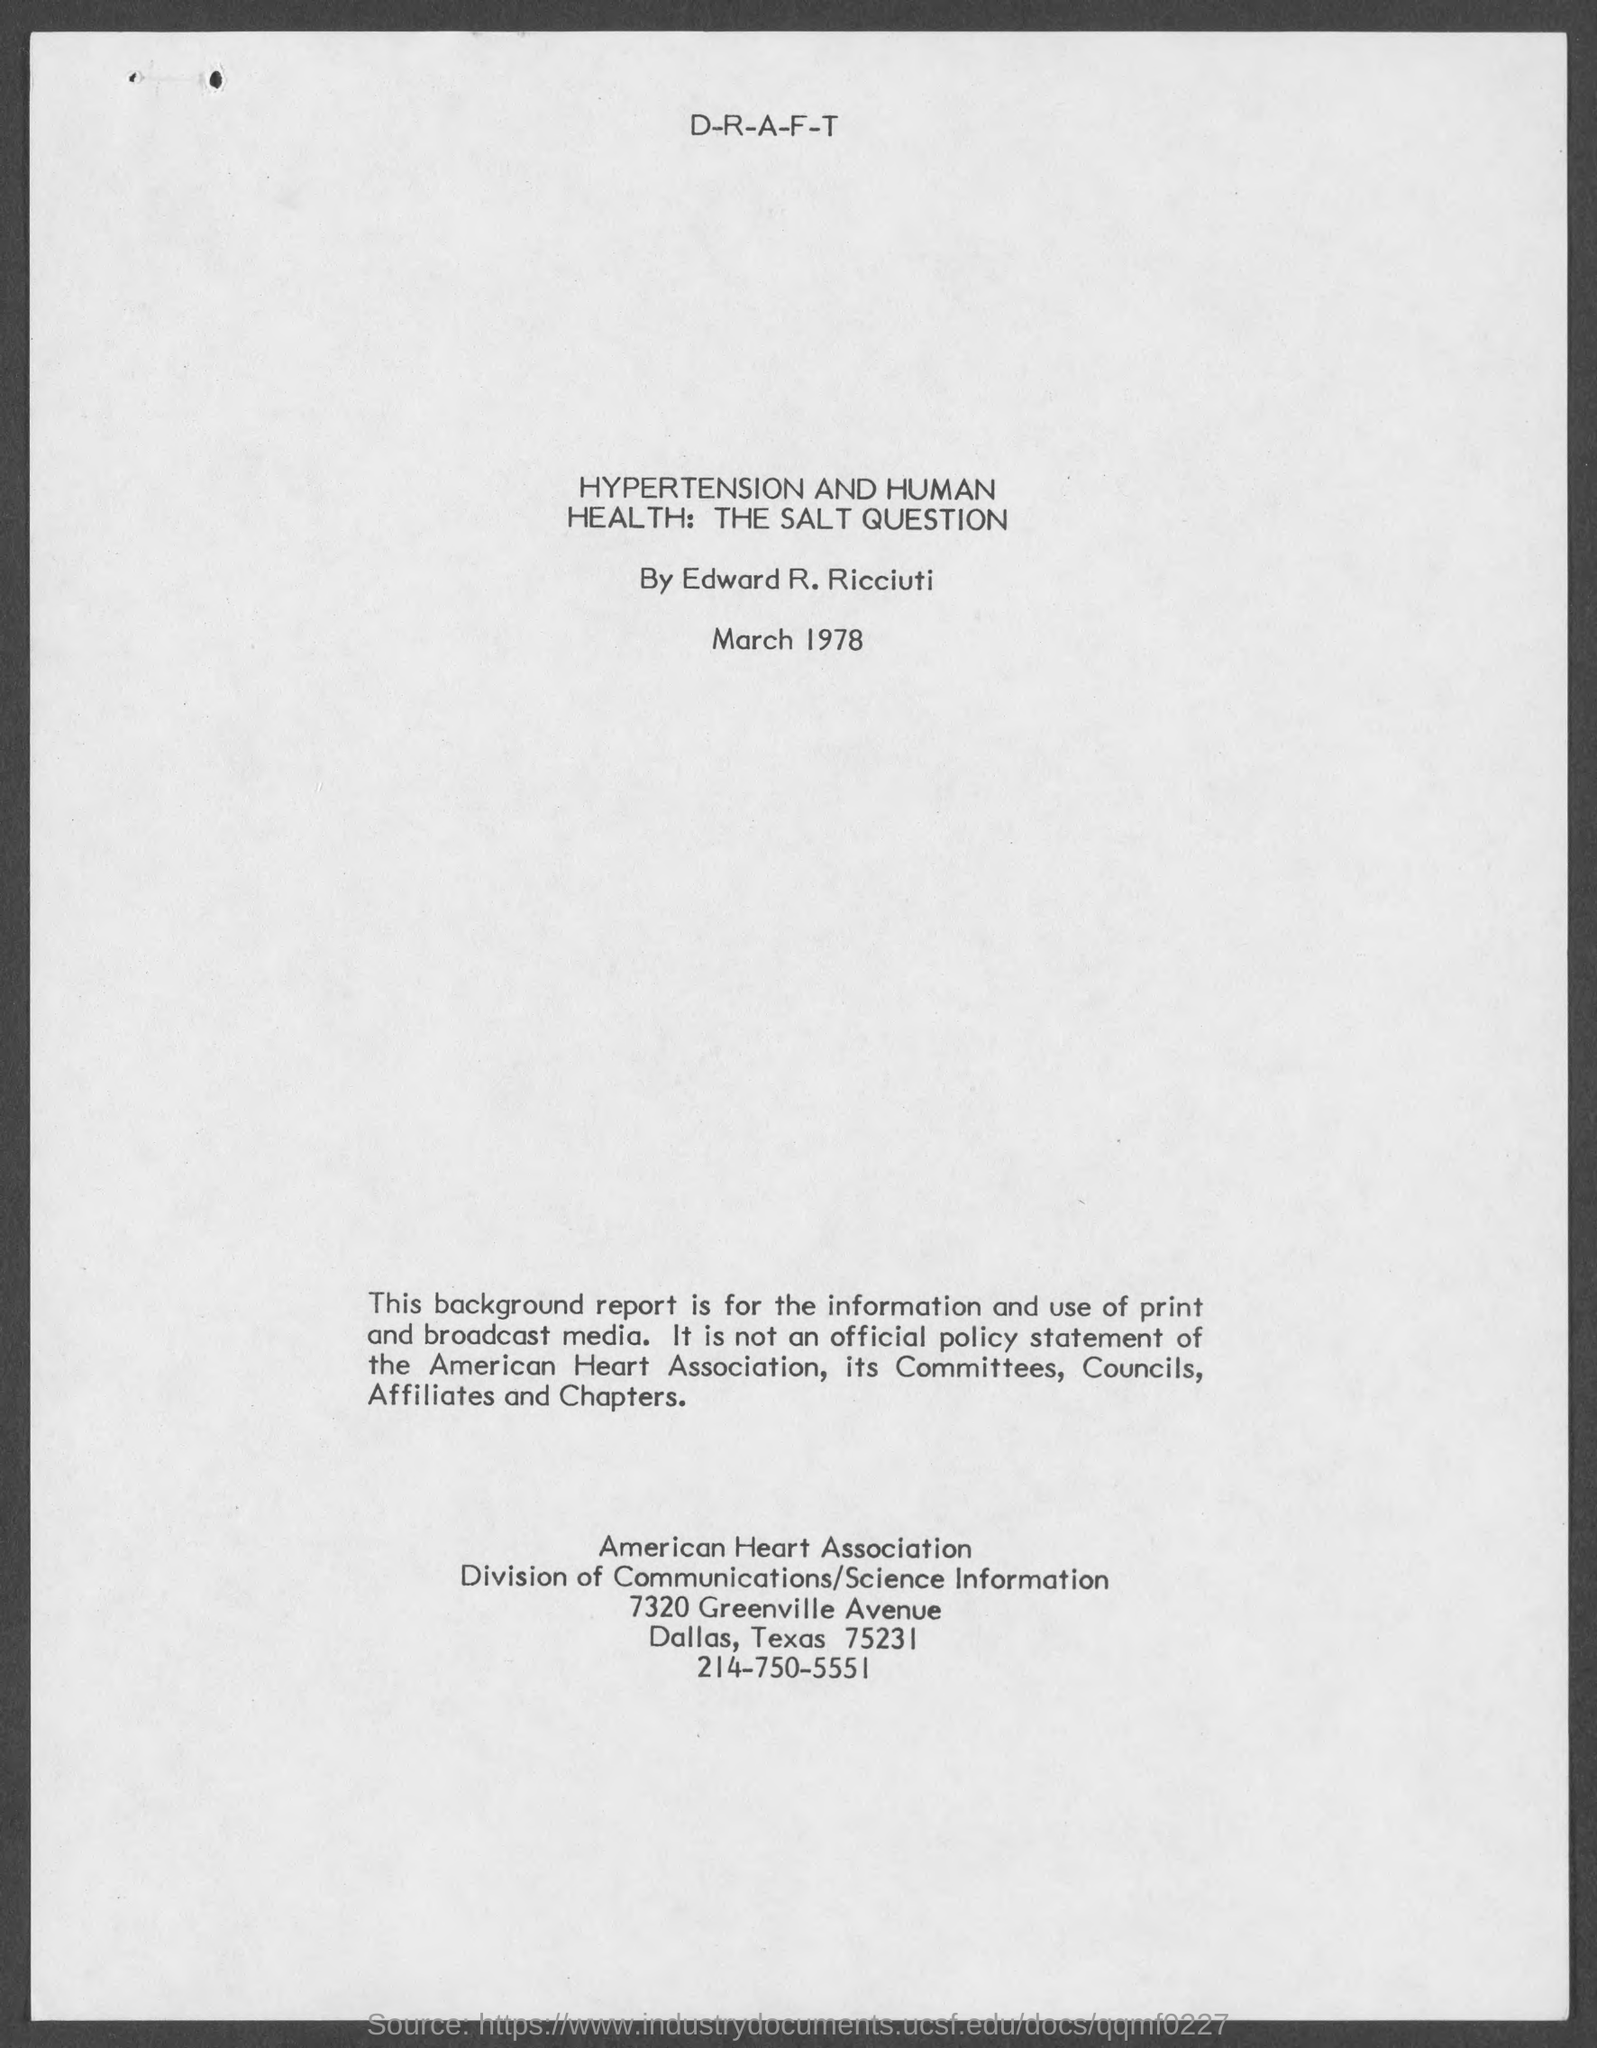Who worked on hypertension and human health. the salt question?
Give a very brief answer. Edward R. ricciuti. 